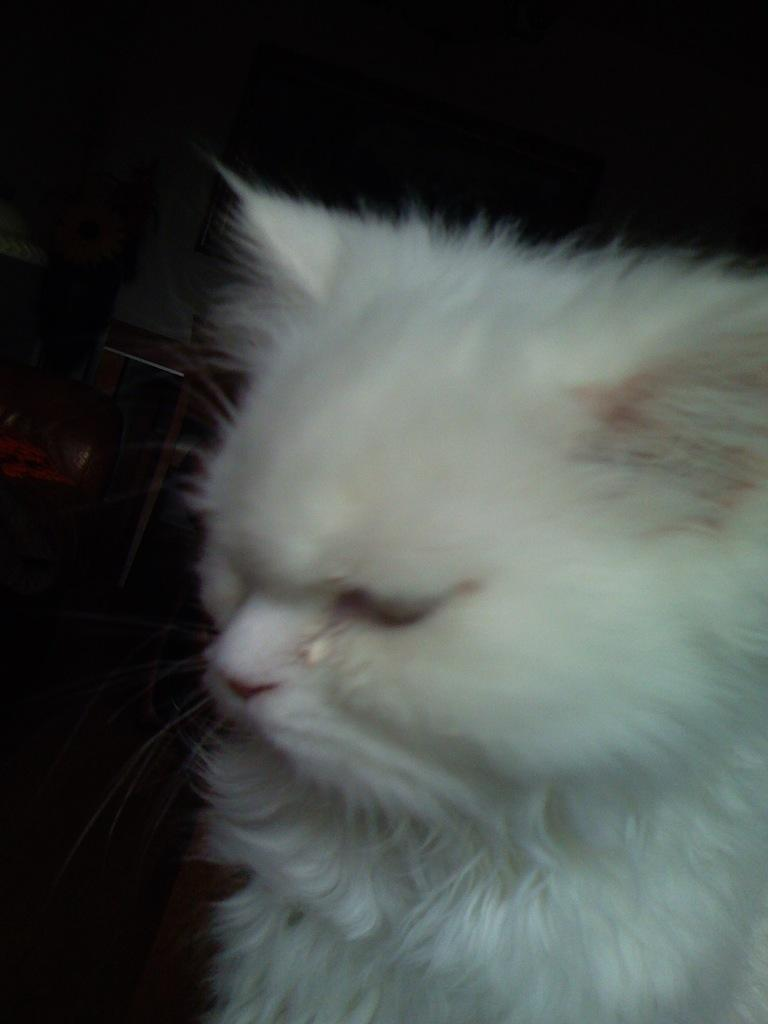What type of animal is in the image? There is a cat in the image. What is the color or condition of the background in the image? The background of the image is dark. Can you see any cherries in the image? There are no cherries present in the image. Is the cat's dad visible in the image? There is no indication of the cat's dad in the image. 